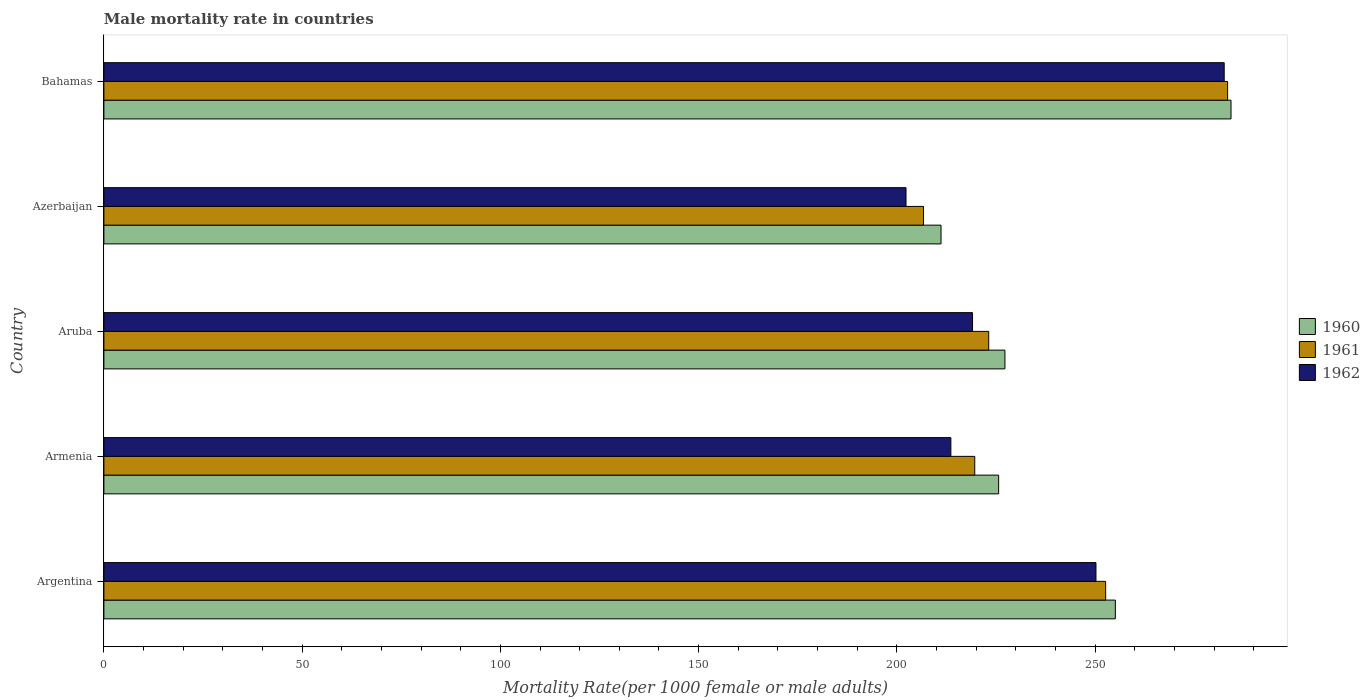How many groups of bars are there?
Make the answer very short. 5. Are the number of bars on each tick of the Y-axis equal?
Your response must be concise. Yes. How many bars are there on the 5th tick from the top?
Offer a very short reply. 3. What is the label of the 4th group of bars from the top?
Offer a very short reply. Armenia. In how many cases, is the number of bars for a given country not equal to the number of legend labels?
Offer a very short reply. 0. What is the male mortality rate in 1960 in Azerbaijan?
Give a very brief answer. 211.14. Across all countries, what is the maximum male mortality rate in 1962?
Offer a terse response. 282.56. Across all countries, what is the minimum male mortality rate in 1960?
Make the answer very short. 211.14. In which country was the male mortality rate in 1961 maximum?
Make the answer very short. Bahamas. In which country was the male mortality rate in 1960 minimum?
Make the answer very short. Azerbaijan. What is the total male mortality rate in 1960 in the graph?
Give a very brief answer. 1203.46. What is the difference between the male mortality rate in 1960 in Aruba and that in Azerbaijan?
Your answer should be very brief. 16.11. What is the difference between the male mortality rate in 1961 in Bahamas and the male mortality rate in 1962 in Aruba?
Provide a short and direct response. 64.34. What is the average male mortality rate in 1962 per country?
Give a very brief answer. 233.56. What is the difference between the male mortality rate in 1960 and male mortality rate in 1962 in Argentina?
Keep it short and to the point. 4.89. What is the ratio of the male mortality rate in 1960 in Aruba to that in Bahamas?
Ensure brevity in your answer.  0.8. Is the male mortality rate in 1961 in Argentina less than that in Bahamas?
Offer a very short reply. Yes. What is the difference between the highest and the second highest male mortality rate in 1961?
Your response must be concise. 30.76. What is the difference between the highest and the lowest male mortality rate in 1960?
Make the answer very short. 73.14. Is the sum of the male mortality rate in 1960 in Argentina and Azerbaijan greater than the maximum male mortality rate in 1961 across all countries?
Give a very brief answer. Yes. Is it the case that in every country, the sum of the male mortality rate in 1962 and male mortality rate in 1960 is greater than the male mortality rate in 1961?
Your answer should be compact. Yes. Are all the bars in the graph horizontal?
Offer a terse response. Yes. How many countries are there in the graph?
Provide a succinct answer. 5. What is the difference between two consecutive major ticks on the X-axis?
Offer a terse response. 50. What is the title of the graph?
Provide a succinct answer. Male mortality rate in countries. Does "1991" appear as one of the legend labels in the graph?
Provide a short and direct response. No. What is the label or title of the X-axis?
Make the answer very short. Mortality Rate(per 1000 female or male adults). What is the Mortality Rate(per 1000 female or male adults) in 1960 in Argentina?
Keep it short and to the point. 255.11. What is the Mortality Rate(per 1000 female or male adults) of 1961 in Argentina?
Make the answer very short. 252.66. What is the Mortality Rate(per 1000 female or male adults) in 1962 in Argentina?
Your answer should be very brief. 250.22. What is the Mortality Rate(per 1000 female or male adults) of 1960 in Armenia?
Your answer should be very brief. 225.67. What is the Mortality Rate(per 1000 female or male adults) of 1961 in Armenia?
Ensure brevity in your answer.  219.65. What is the Mortality Rate(per 1000 female or male adults) of 1962 in Armenia?
Offer a terse response. 213.63. What is the Mortality Rate(per 1000 female or male adults) of 1960 in Aruba?
Ensure brevity in your answer.  227.25. What is the Mortality Rate(per 1000 female or male adults) of 1961 in Aruba?
Make the answer very short. 223.17. What is the Mortality Rate(per 1000 female or male adults) in 1962 in Aruba?
Give a very brief answer. 219.09. What is the Mortality Rate(per 1000 female or male adults) of 1960 in Azerbaijan?
Ensure brevity in your answer.  211.14. What is the Mortality Rate(per 1000 female or male adults) in 1961 in Azerbaijan?
Your answer should be very brief. 206.73. What is the Mortality Rate(per 1000 female or male adults) in 1962 in Azerbaijan?
Provide a succinct answer. 202.31. What is the Mortality Rate(per 1000 female or male adults) in 1960 in Bahamas?
Keep it short and to the point. 284.28. What is the Mortality Rate(per 1000 female or male adults) in 1961 in Bahamas?
Offer a very short reply. 283.42. What is the Mortality Rate(per 1000 female or male adults) in 1962 in Bahamas?
Provide a short and direct response. 282.56. Across all countries, what is the maximum Mortality Rate(per 1000 female or male adults) of 1960?
Offer a very short reply. 284.28. Across all countries, what is the maximum Mortality Rate(per 1000 female or male adults) in 1961?
Your answer should be compact. 283.42. Across all countries, what is the maximum Mortality Rate(per 1000 female or male adults) of 1962?
Offer a very short reply. 282.56. Across all countries, what is the minimum Mortality Rate(per 1000 female or male adults) of 1960?
Offer a terse response. 211.14. Across all countries, what is the minimum Mortality Rate(per 1000 female or male adults) in 1961?
Offer a very short reply. 206.73. Across all countries, what is the minimum Mortality Rate(per 1000 female or male adults) in 1962?
Your response must be concise. 202.31. What is the total Mortality Rate(per 1000 female or male adults) in 1960 in the graph?
Your answer should be compact. 1203.46. What is the total Mortality Rate(per 1000 female or male adults) in 1961 in the graph?
Make the answer very short. 1185.63. What is the total Mortality Rate(per 1000 female or male adults) of 1962 in the graph?
Make the answer very short. 1167.8. What is the difference between the Mortality Rate(per 1000 female or male adults) of 1960 in Argentina and that in Armenia?
Keep it short and to the point. 29.44. What is the difference between the Mortality Rate(per 1000 female or male adults) of 1961 in Argentina and that in Armenia?
Provide a short and direct response. 33.02. What is the difference between the Mortality Rate(per 1000 female or male adults) in 1962 in Argentina and that in Armenia?
Make the answer very short. 36.59. What is the difference between the Mortality Rate(per 1000 female or male adults) in 1960 in Argentina and that in Aruba?
Your answer should be very brief. 27.86. What is the difference between the Mortality Rate(per 1000 female or male adults) in 1961 in Argentina and that in Aruba?
Offer a very short reply. 29.49. What is the difference between the Mortality Rate(per 1000 female or male adults) of 1962 in Argentina and that in Aruba?
Make the answer very short. 31.13. What is the difference between the Mortality Rate(per 1000 female or male adults) of 1960 in Argentina and that in Azerbaijan?
Provide a succinct answer. 43.96. What is the difference between the Mortality Rate(per 1000 female or male adults) in 1961 in Argentina and that in Azerbaijan?
Provide a short and direct response. 45.94. What is the difference between the Mortality Rate(per 1000 female or male adults) of 1962 in Argentina and that in Azerbaijan?
Your response must be concise. 47.91. What is the difference between the Mortality Rate(per 1000 female or male adults) of 1960 in Argentina and that in Bahamas?
Ensure brevity in your answer.  -29.17. What is the difference between the Mortality Rate(per 1000 female or male adults) in 1961 in Argentina and that in Bahamas?
Provide a short and direct response. -30.76. What is the difference between the Mortality Rate(per 1000 female or male adults) in 1962 in Argentina and that in Bahamas?
Your response must be concise. -32.34. What is the difference between the Mortality Rate(per 1000 female or male adults) in 1960 in Armenia and that in Aruba?
Provide a succinct answer. -1.58. What is the difference between the Mortality Rate(per 1000 female or male adults) of 1961 in Armenia and that in Aruba?
Offer a terse response. -3.52. What is the difference between the Mortality Rate(per 1000 female or male adults) in 1962 in Armenia and that in Aruba?
Make the answer very short. -5.46. What is the difference between the Mortality Rate(per 1000 female or male adults) of 1960 in Armenia and that in Azerbaijan?
Provide a succinct answer. 14.53. What is the difference between the Mortality Rate(per 1000 female or male adults) of 1961 in Armenia and that in Azerbaijan?
Your answer should be very brief. 12.92. What is the difference between the Mortality Rate(per 1000 female or male adults) in 1962 in Armenia and that in Azerbaijan?
Provide a short and direct response. 11.32. What is the difference between the Mortality Rate(per 1000 female or male adults) in 1960 in Armenia and that in Bahamas?
Offer a terse response. -58.61. What is the difference between the Mortality Rate(per 1000 female or male adults) of 1961 in Armenia and that in Bahamas?
Your response must be concise. -63.77. What is the difference between the Mortality Rate(per 1000 female or male adults) of 1962 in Armenia and that in Bahamas?
Your answer should be very brief. -68.94. What is the difference between the Mortality Rate(per 1000 female or male adults) of 1960 in Aruba and that in Azerbaijan?
Provide a short and direct response. 16.11. What is the difference between the Mortality Rate(per 1000 female or male adults) in 1961 in Aruba and that in Azerbaijan?
Offer a very short reply. 16.44. What is the difference between the Mortality Rate(per 1000 female or male adults) of 1962 in Aruba and that in Azerbaijan?
Your answer should be very brief. 16.78. What is the difference between the Mortality Rate(per 1000 female or male adults) of 1960 in Aruba and that in Bahamas?
Your response must be concise. -57.03. What is the difference between the Mortality Rate(per 1000 female or male adults) in 1961 in Aruba and that in Bahamas?
Give a very brief answer. -60.25. What is the difference between the Mortality Rate(per 1000 female or male adults) in 1962 in Aruba and that in Bahamas?
Your answer should be compact. -63.48. What is the difference between the Mortality Rate(per 1000 female or male adults) of 1960 in Azerbaijan and that in Bahamas?
Your answer should be compact. -73.14. What is the difference between the Mortality Rate(per 1000 female or male adults) in 1961 in Azerbaijan and that in Bahamas?
Give a very brief answer. -76.7. What is the difference between the Mortality Rate(per 1000 female or male adults) in 1962 in Azerbaijan and that in Bahamas?
Offer a terse response. -80.25. What is the difference between the Mortality Rate(per 1000 female or male adults) in 1960 in Argentina and the Mortality Rate(per 1000 female or male adults) in 1961 in Armenia?
Keep it short and to the point. 35.46. What is the difference between the Mortality Rate(per 1000 female or male adults) of 1960 in Argentina and the Mortality Rate(per 1000 female or male adults) of 1962 in Armenia?
Provide a succinct answer. 41.48. What is the difference between the Mortality Rate(per 1000 female or male adults) of 1961 in Argentina and the Mortality Rate(per 1000 female or male adults) of 1962 in Armenia?
Your answer should be very brief. 39.04. What is the difference between the Mortality Rate(per 1000 female or male adults) in 1960 in Argentina and the Mortality Rate(per 1000 female or male adults) in 1961 in Aruba?
Provide a succinct answer. 31.94. What is the difference between the Mortality Rate(per 1000 female or male adults) in 1960 in Argentina and the Mortality Rate(per 1000 female or male adults) in 1962 in Aruba?
Make the answer very short. 36.02. What is the difference between the Mortality Rate(per 1000 female or male adults) of 1961 in Argentina and the Mortality Rate(per 1000 female or male adults) of 1962 in Aruba?
Offer a very short reply. 33.58. What is the difference between the Mortality Rate(per 1000 female or male adults) of 1960 in Argentina and the Mortality Rate(per 1000 female or male adults) of 1961 in Azerbaijan?
Your response must be concise. 48.38. What is the difference between the Mortality Rate(per 1000 female or male adults) in 1960 in Argentina and the Mortality Rate(per 1000 female or male adults) in 1962 in Azerbaijan?
Your answer should be very brief. 52.8. What is the difference between the Mortality Rate(per 1000 female or male adults) of 1961 in Argentina and the Mortality Rate(per 1000 female or male adults) of 1962 in Azerbaijan?
Provide a short and direct response. 50.35. What is the difference between the Mortality Rate(per 1000 female or male adults) in 1960 in Argentina and the Mortality Rate(per 1000 female or male adults) in 1961 in Bahamas?
Your answer should be very brief. -28.31. What is the difference between the Mortality Rate(per 1000 female or male adults) of 1960 in Argentina and the Mortality Rate(per 1000 female or male adults) of 1962 in Bahamas?
Make the answer very short. -27.45. What is the difference between the Mortality Rate(per 1000 female or male adults) of 1961 in Argentina and the Mortality Rate(per 1000 female or male adults) of 1962 in Bahamas?
Make the answer very short. -29.9. What is the difference between the Mortality Rate(per 1000 female or male adults) of 1960 in Armenia and the Mortality Rate(per 1000 female or male adults) of 1961 in Aruba?
Give a very brief answer. 2.5. What is the difference between the Mortality Rate(per 1000 female or male adults) of 1960 in Armenia and the Mortality Rate(per 1000 female or male adults) of 1962 in Aruba?
Keep it short and to the point. 6.58. What is the difference between the Mortality Rate(per 1000 female or male adults) in 1961 in Armenia and the Mortality Rate(per 1000 female or male adults) in 1962 in Aruba?
Offer a very short reply. 0.56. What is the difference between the Mortality Rate(per 1000 female or male adults) of 1960 in Armenia and the Mortality Rate(per 1000 female or male adults) of 1961 in Azerbaijan?
Make the answer very short. 18.94. What is the difference between the Mortality Rate(per 1000 female or male adults) of 1960 in Armenia and the Mortality Rate(per 1000 female or male adults) of 1962 in Azerbaijan?
Offer a very short reply. 23.36. What is the difference between the Mortality Rate(per 1000 female or male adults) in 1961 in Armenia and the Mortality Rate(per 1000 female or male adults) in 1962 in Azerbaijan?
Make the answer very short. 17.34. What is the difference between the Mortality Rate(per 1000 female or male adults) of 1960 in Armenia and the Mortality Rate(per 1000 female or male adults) of 1961 in Bahamas?
Provide a short and direct response. -57.75. What is the difference between the Mortality Rate(per 1000 female or male adults) of 1960 in Armenia and the Mortality Rate(per 1000 female or male adults) of 1962 in Bahamas?
Your answer should be compact. -56.89. What is the difference between the Mortality Rate(per 1000 female or male adults) of 1961 in Armenia and the Mortality Rate(per 1000 female or male adults) of 1962 in Bahamas?
Your response must be concise. -62.91. What is the difference between the Mortality Rate(per 1000 female or male adults) of 1960 in Aruba and the Mortality Rate(per 1000 female or male adults) of 1961 in Azerbaijan?
Make the answer very short. 20.53. What is the difference between the Mortality Rate(per 1000 female or male adults) of 1960 in Aruba and the Mortality Rate(per 1000 female or male adults) of 1962 in Azerbaijan?
Your response must be concise. 24.94. What is the difference between the Mortality Rate(per 1000 female or male adults) in 1961 in Aruba and the Mortality Rate(per 1000 female or male adults) in 1962 in Azerbaijan?
Offer a terse response. 20.86. What is the difference between the Mortality Rate(per 1000 female or male adults) in 1960 in Aruba and the Mortality Rate(per 1000 female or male adults) in 1961 in Bahamas?
Give a very brief answer. -56.17. What is the difference between the Mortality Rate(per 1000 female or male adults) of 1960 in Aruba and the Mortality Rate(per 1000 female or male adults) of 1962 in Bahamas?
Make the answer very short. -55.31. What is the difference between the Mortality Rate(per 1000 female or male adults) of 1961 in Aruba and the Mortality Rate(per 1000 female or male adults) of 1962 in Bahamas?
Keep it short and to the point. -59.39. What is the difference between the Mortality Rate(per 1000 female or male adults) of 1960 in Azerbaijan and the Mortality Rate(per 1000 female or male adults) of 1961 in Bahamas?
Ensure brevity in your answer.  -72.28. What is the difference between the Mortality Rate(per 1000 female or male adults) of 1960 in Azerbaijan and the Mortality Rate(per 1000 female or male adults) of 1962 in Bahamas?
Your answer should be compact. -71.42. What is the difference between the Mortality Rate(per 1000 female or male adults) in 1961 in Azerbaijan and the Mortality Rate(per 1000 female or male adults) in 1962 in Bahamas?
Your response must be concise. -75.84. What is the average Mortality Rate(per 1000 female or male adults) in 1960 per country?
Offer a terse response. 240.69. What is the average Mortality Rate(per 1000 female or male adults) of 1961 per country?
Keep it short and to the point. 237.13. What is the average Mortality Rate(per 1000 female or male adults) in 1962 per country?
Keep it short and to the point. 233.56. What is the difference between the Mortality Rate(per 1000 female or male adults) in 1960 and Mortality Rate(per 1000 female or male adults) in 1961 in Argentina?
Offer a terse response. 2.44. What is the difference between the Mortality Rate(per 1000 female or male adults) in 1960 and Mortality Rate(per 1000 female or male adults) in 1962 in Argentina?
Your answer should be compact. 4.89. What is the difference between the Mortality Rate(per 1000 female or male adults) of 1961 and Mortality Rate(per 1000 female or male adults) of 1962 in Argentina?
Keep it short and to the point. 2.44. What is the difference between the Mortality Rate(per 1000 female or male adults) of 1960 and Mortality Rate(per 1000 female or male adults) of 1961 in Armenia?
Keep it short and to the point. 6.02. What is the difference between the Mortality Rate(per 1000 female or male adults) of 1960 and Mortality Rate(per 1000 female or male adults) of 1962 in Armenia?
Your answer should be compact. 12.04. What is the difference between the Mortality Rate(per 1000 female or male adults) of 1961 and Mortality Rate(per 1000 female or male adults) of 1962 in Armenia?
Your answer should be very brief. 6.02. What is the difference between the Mortality Rate(per 1000 female or male adults) of 1960 and Mortality Rate(per 1000 female or male adults) of 1961 in Aruba?
Offer a very short reply. 4.08. What is the difference between the Mortality Rate(per 1000 female or male adults) in 1960 and Mortality Rate(per 1000 female or male adults) in 1962 in Aruba?
Your answer should be very brief. 8.17. What is the difference between the Mortality Rate(per 1000 female or male adults) of 1961 and Mortality Rate(per 1000 female or male adults) of 1962 in Aruba?
Provide a short and direct response. 4.08. What is the difference between the Mortality Rate(per 1000 female or male adults) in 1960 and Mortality Rate(per 1000 female or male adults) in 1961 in Azerbaijan?
Give a very brief answer. 4.42. What is the difference between the Mortality Rate(per 1000 female or male adults) of 1960 and Mortality Rate(per 1000 female or male adults) of 1962 in Azerbaijan?
Give a very brief answer. 8.84. What is the difference between the Mortality Rate(per 1000 female or male adults) in 1961 and Mortality Rate(per 1000 female or male adults) in 1962 in Azerbaijan?
Your answer should be very brief. 4.42. What is the difference between the Mortality Rate(per 1000 female or male adults) of 1960 and Mortality Rate(per 1000 female or male adults) of 1961 in Bahamas?
Make the answer very short. 0.86. What is the difference between the Mortality Rate(per 1000 female or male adults) in 1960 and Mortality Rate(per 1000 female or male adults) in 1962 in Bahamas?
Make the answer very short. 1.72. What is the difference between the Mortality Rate(per 1000 female or male adults) of 1961 and Mortality Rate(per 1000 female or male adults) of 1962 in Bahamas?
Your answer should be compact. 0.86. What is the ratio of the Mortality Rate(per 1000 female or male adults) of 1960 in Argentina to that in Armenia?
Your answer should be very brief. 1.13. What is the ratio of the Mortality Rate(per 1000 female or male adults) in 1961 in Argentina to that in Armenia?
Your answer should be compact. 1.15. What is the ratio of the Mortality Rate(per 1000 female or male adults) of 1962 in Argentina to that in Armenia?
Make the answer very short. 1.17. What is the ratio of the Mortality Rate(per 1000 female or male adults) in 1960 in Argentina to that in Aruba?
Your answer should be very brief. 1.12. What is the ratio of the Mortality Rate(per 1000 female or male adults) in 1961 in Argentina to that in Aruba?
Your answer should be compact. 1.13. What is the ratio of the Mortality Rate(per 1000 female or male adults) in 1962 in Argentina to that in Aruba?
Keep it short and to the point. 1.14. What is the ratio of the Mortality Rate(per 1000 female or male adults) of 1960 in Argentina to that in Azerbaijan?
Your response must be concise. 1.21. What is the ratio of the Mortality Rate(per 1000 female or male adults) of 1961 in Argentina to that in Azerbaijan?
Make the answer very short. 1.22. What is the ratio of the Mortality Rate(per 1000 female or male adults) of 1962 in Argentina to that in Azerbaijan?
Your response must be concise. 1.24. What is the ratio of the Mortality Rate(per 1000 female or male adults) in 1960 in Argentina to that in Bahamas?
Your response must be concise. 0.9. What is the ratio of the Mortality Rate(per 1000 female or male adults) of 1961 in Argentina to that in Bahamas?
Provide a short and direct response. 0.89. What is the ratio of the Mortality Rate(per 1000 female or male adults) of 1962 in Argentina to that in Bahamas?
Provide a short and direct response. 0.89. What is the ratio of the Mortality Rate(per 1000 female or male adults) of 1960 in Armenia to that in Aruba?
Keep it short and to the point. 0.99. What is the ratio of the Mortality Rate(per 1000 female or male adults) in 1961 in Armenia to that in Aruba?
Make the answer very short. 0.98. What is the ratio of the Mortality Rate(per 1000 female or male adults) of 1962 in Armenia to that in Aruba?
Make the answer very short. 0.98. What is the ratio of the Mortality Rate(per 1000 female or male adults) of 1960 in Armenia to that in Azerbaijan?
Your response must be concise. 1.07. What is the ratio of the Mortality Rate(per 1000 female or male adults) in 1962 in Armenia to that in Azerbaijan?
Make the answer very short. 1.06. What is the ratio of the Mortality Rate(per 1000 female or male adults) in 1960 in Armenia to that in Bahamas?
Your answer should be compact. 0.79. What is the ratio of the Mortality Rate(per 1000 female or male adults) in 1961 in Armenia to that in Bahamas?
Provide a succinct answer. 0.78. What is the ratio of the Mortality Rate(per 1000 female or male adults) in 1962 in Armenia to that in Bahamas?
Your answer should be compact. 0.76. What is the ratio of the Mortality Rate(per 1000 female or male adults) of 1960 in Aruba to that in Azerbaijan?
Offer a very short reply. 1.08. What is the ratio of the Mortality Rate(per 1000 female or male adults) of 1961 in Aruba to that in Azerbaijan?
Offer a terse response. 1.08. What is the ratio of the Mortality Rate(per 1000 female or male adults) of 1962 in Aruba to that in Azerbaijan?
Ensure brevity in your answer.  1.08. What is the ratio of the Mortality Rate(per 1000 female or male adults) in 1960 in Aruba to that in Bahamas?
Keep it short and to the point. 0.8. What is the ratio of the Mortality Rate(per 1000 female or male adults) in 1961 in Aruba to that in Bahamas?
Provide a succinct answer. 0.79. What is the ratio of the Mortality Rate(per 1000 female or male adults) of 1962 in Aruba to that in Bahamas?
Your answer should be very brief. 0.78. What is the ratio of the Mortality Rate(per 1000 female or male adults) in 1960 in Azerbaijan to that in Bahamas?
Offer a very short reply. 0.74. What is the ratio of the Mortality Rate(per 1000 female or male adults) of 1961 in Azerbaijan to that in Bahamas?
Offer a terse response. 0.73. What is the ratio of the Mortality Rate(per 1000 female or male adults) in 1962 in Azerbaijan to that in Bahamas?
Your answer should be compact. 0.72. What is the difference between the highest and the second highest Mortality Rate(per 1000 female or male adults) of 1960?
Your response must be concise. 29.17. What is the difference between the highest and the second highest Mortality Rate(per 1000 female or male adults) in 1961?
Provide a succinct answer. 30.76. What is the difference between the highest and the second highest Mortality Rate(per 1000 female or male adults) of 1962?
Provide a succinct answer. 32.34. What is the difference between the highest and the lowest Mortality Rate(per 1000 female or male adults) in 1960?
Give a very brief answer. 73.14. What is the difference between the highest and the lowest Mortality Rate(per 1000 female or male adults) in 1961?
Keep it short and to the point. 76.7. What is the difference between the highest and the lowest Mortality Rate(per 1000 female or male adults) of 1962?
Offer a terse response. 80.25. 